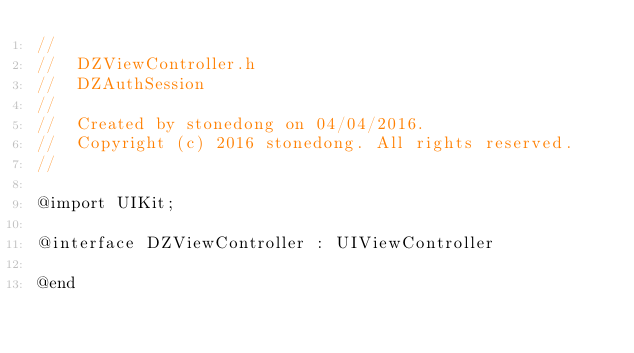<code> <loc_0><loc_0><loc_500><loc_500><_C_>//
//  DZViewController.h
//  DZAuthSession
//
//  Created by stonedong on 04/04/2016.
//  Copyright (c) 2016 stonedong. All rights reserved.
//

@import UIKit;

@interface DZViewController : UIViewController

@end
</code> 